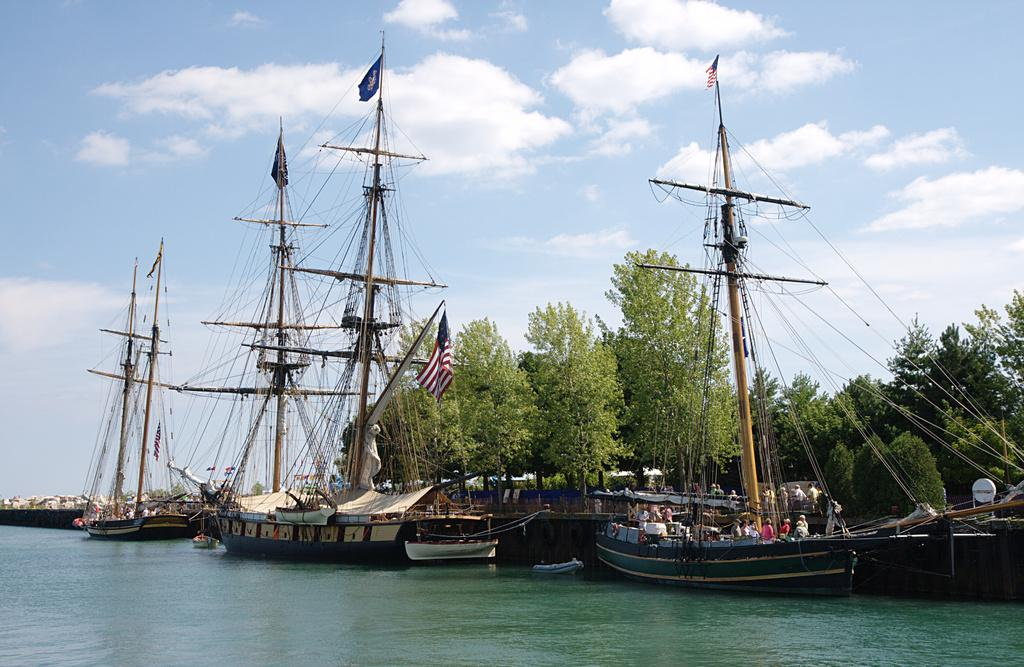What is located at the bottom of the image? There is water at the bottom of the image. What can be seen in the middle of the image? There are boats in the middle of the image. What objects are present in the image that represent a symbol or country? Flags are present in the image. What type of infrastructure is visible in the image? Cables are visible in the image. Who or what is present in the image? There are people in the image. What type of vegetation is present in the image? Trees are present in the image. What part of the natural environment is visible in the image? The sky is visible in the image. What type of weather can be inferred from the image? Clouds are present in the image, suggesting that it might be a partly cloudy day. What type of bag is being used by the people in the image? There is no bag visible in the image; the people are not carrying any bags. What authority is represented by the flags in the image? The flags in the image represent different countries or organizations, but the specific authority they represent cannot be determined from the image alone. 